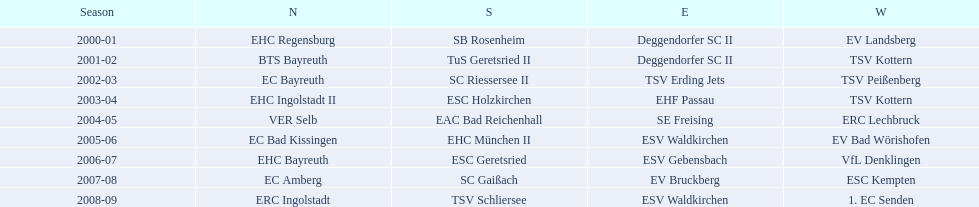How many champions are listend in the north? 9. Could you parse the entire table? {'header': ['Season', 'N', 'S', 'E', 'W'], 'rows': [['2000-01', 'EHC Regensburg', 'SB Rosenheim', 'Deggendorfer SC II', 'EV Landsberg'], ['2001-02', 'BTS Bayreuth', 'TuS Geretsried II', 'Deggendorfer SC II', 'TSV Kottern'], ['2002-03', 'EC Bayreuth', 'SC Riessersee II', 'TSV Erding Jets', 'TSV Peißenberg'], ['2003-04', 'EHC Ingolstadt II', 'ESC Holzkirchen', 'EHF Passau', 'TSV Kottern'], ['2004-05', 'VER Selb', 'EAC Bad Reichenhall', 'SE Freising', 'ERC Lechbruck'], ['2005-06', 'EC Bad Kissingen', 'EHC München II', 'ESV Waldkirchen', 'EV Bad Wörishofen'], ['2006-07', 'EHC Bayreuth', 'ESC Geretsried', 'ESV Gebensbach', 'VfL Denklingen'], ['2007-08', 'EC Amberg', 'SC Gaißach', 'EV Bruckberg', 'ESC Kempten'], ['2008-09', 'ERC Ingolstadt', 'TSV Schliersee', 'ESV Waldkirchen', '1. EC Senden']]} 